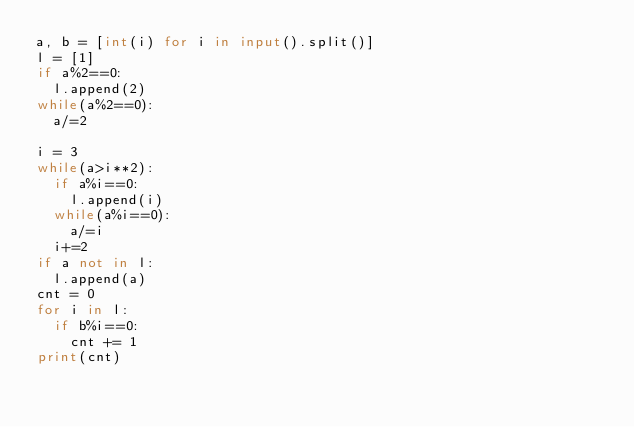<code> <loc_0><loc_0><loc_500><loc_500><_Python_>a, b = [int(i) for i in input().split()]
l = [1]
if a%2==0:
  l.append(2)
while(a%2==0):
  a/=2

i = 3
while(a>i**2):
  if a%i==0:
    l.append(i)
  while(a%i==0):
    a/=i
  i+=2
if a not in l:
  l.append(a)
cnt = 0
for i in l:
  if b%i==0:
    cnt += 1
print(cnt)</code> 